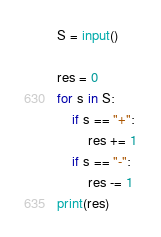<code> <loc_0><loc_0><loc_500><loc_500><_Python_>S = input()

res = 0
for s in S:
    if s == "+":
        res += 1
    if s == "-":
        res -= 1
print(res)</code> 